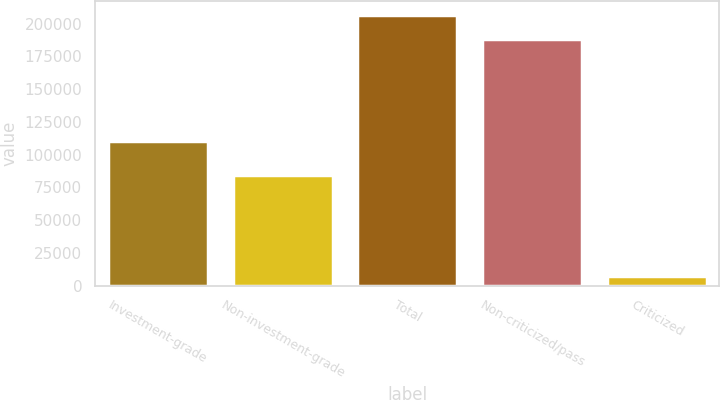Convert chart. <chart><loc_0><loc_0><loc_500><loc_500><bar_chart><fcel>Investment-grade<fcel>Non-investment-grade<fcel>Total<fcel>Non-criticized/pass<fcel>Criticized<nl><fcel>110249<fcel>84826<fcel>206884<fcel>188076<fcel>6999<nl></chart> 